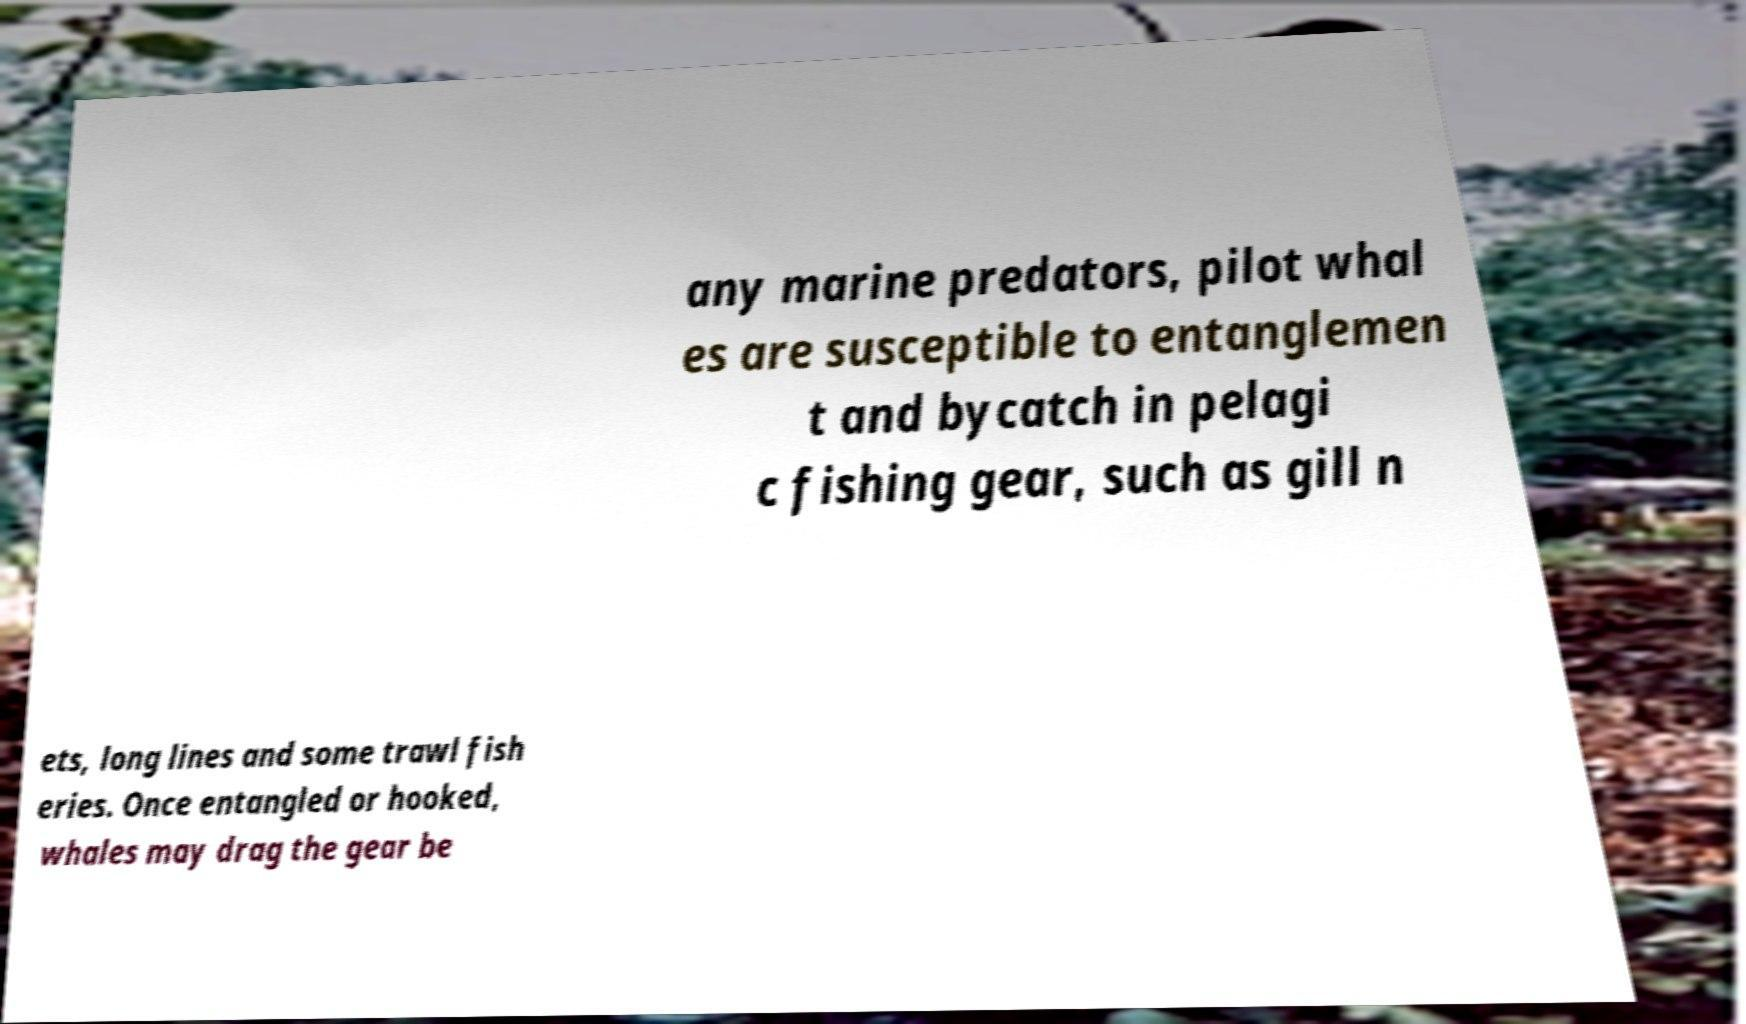Could you assist in decoding the text presented in this image and type it out clearly? any marine predators, pilot whal es are susceptible to entanglemen t and bycatch in pelagi c fishing gear, such as gill n ets, long lines and some trawl fish eries. Once entangled or hooked, whales may drag the gear be 